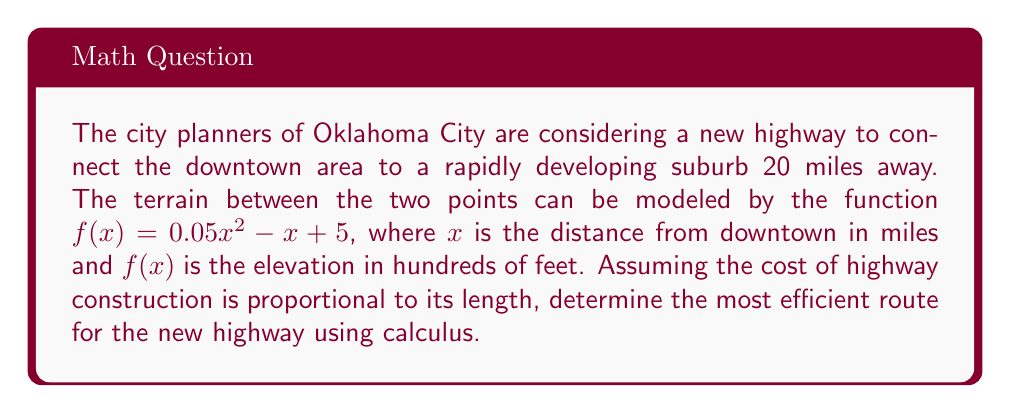Teach me how to tackle this problem. To find the most efficient route, we need to minimize the length of the highway. This can be done using the arc length formula from calculus.

Step 1: Set up the arc length integral
The arc length formula is:
$$L = \int_a^b \sqrt{1 + [f'(x)]^2} dx$$
where $a = 0$ and $b = 20$ (miles)

Step 2: Find $f'(x)$
$$f'(x) = 0.1x - 1$$

Step 3: Substitute into the arc length formula
$$L = \int_0^{20} \sqrt{1 + (0.1x - 1)^2} dx$$

Step 4: This integral is complex to solve analytically, so we'll use numerical integration methods. Using a computer algebra system or numerical integration tool, we find:
$$L \approx 20.10 \text{ miles}$$

Step 5: Compare to a straight line
The straight-line distance between the two points is:
$$\sqrt{20^2 + [f(20) - f(0)]^2} = \sqrt{400 + (5 - 5)^2} = 20 \text{ miles}$$

The difference between the arc length and the straight line is only about 0.10 miles or 528 feet.

Step 6: Consider the practical implications
Given the minimal difference in length and the significantly reduced complexity of construction, the most efficient route is a straight line between the two points.
Answer: A straight line path 